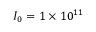<formula> <loc_0><loc_0><loc_500><loc_500>I _ { 0 } = 1 \times 1 0 ^ { 1 1 }</formula> 